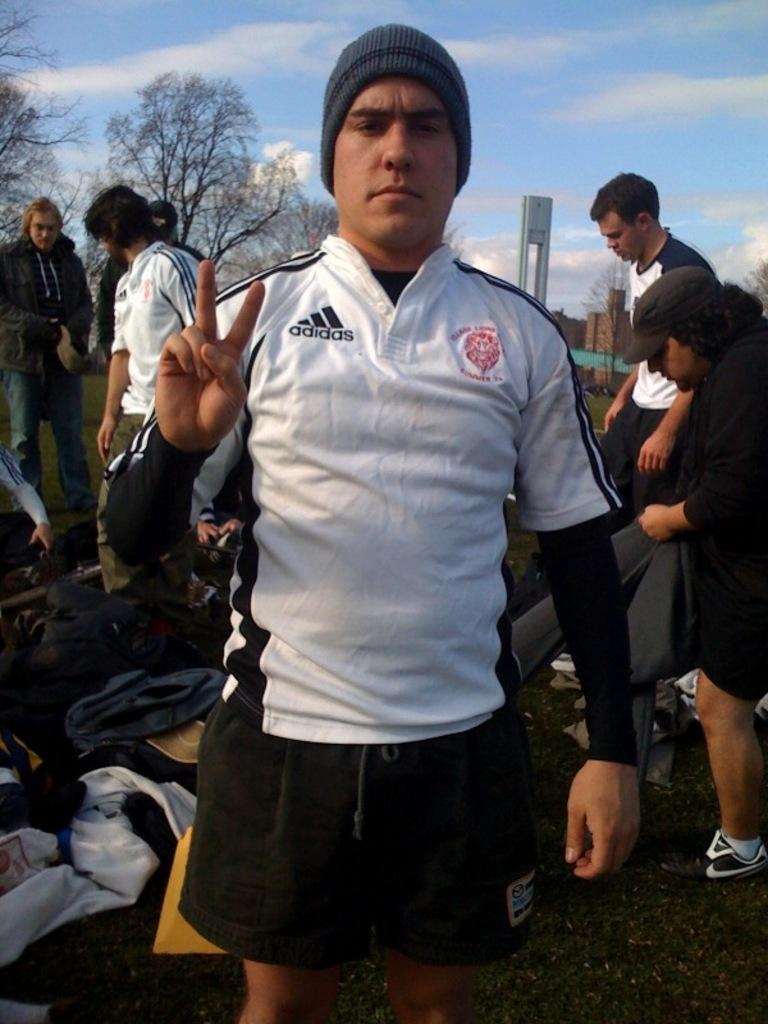<image>
Describe the image concisely. A man in an Adidas shirt making a peace sign. 